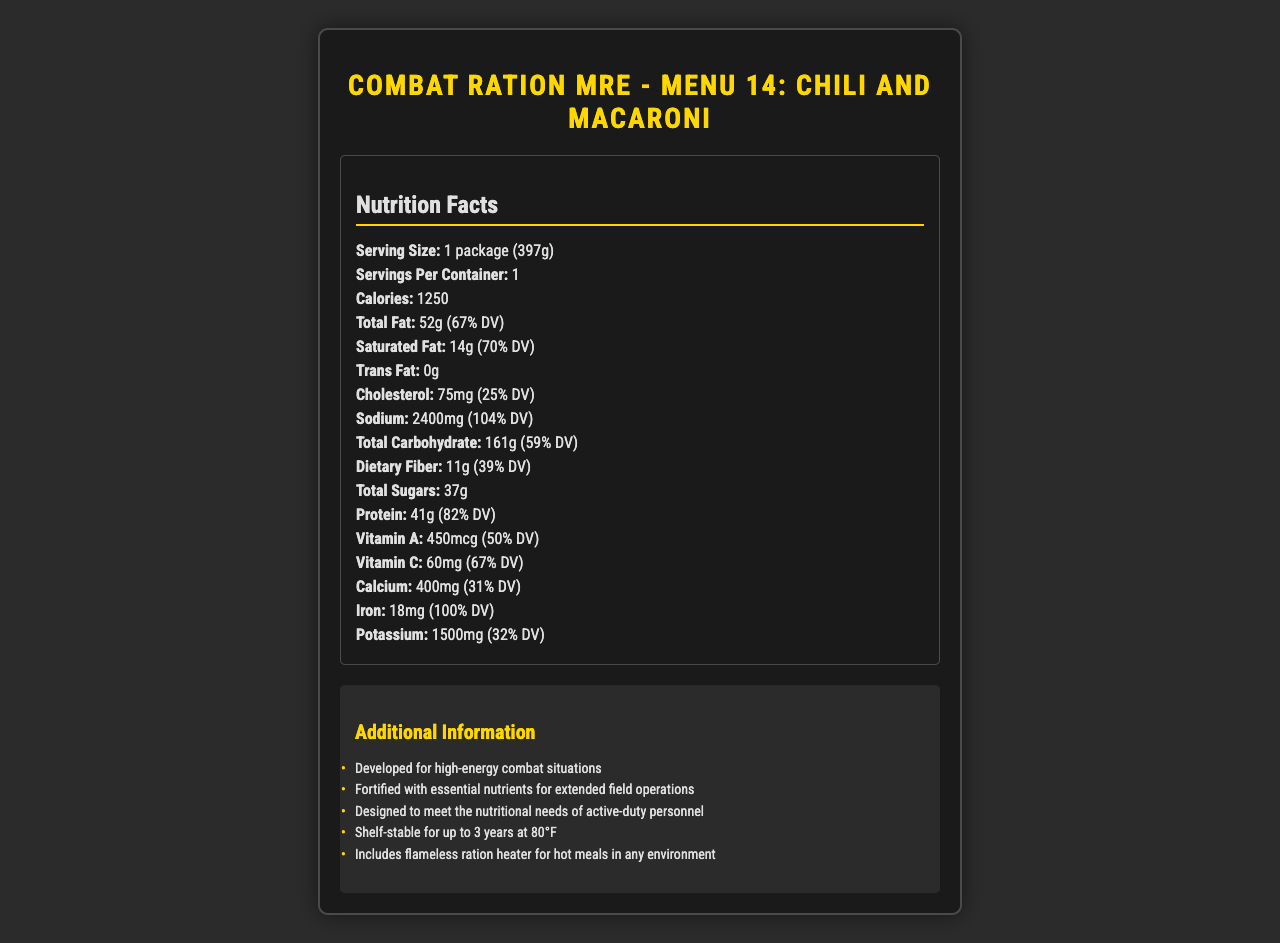what is the total fat content? The document states the total fat content is 52g, which is specified in the "Total Fat" section.
Answer: 52g how much calcium is in the MRE? In the nutrition facts, it is mentioned that Calcium amounts to 400mg.
Answer: 400mg what's the daily value percentage of vitamin B12? The document indicates that Vitamin B12 makes up 250% of the daily value.
Answer: 250% what is the serving size of this MRE? The serving size listed is "1 package (397g)".
Answer: 1 package (397g) how much protein is in the MRE? The protein content of the MRE is specified as 41g.
Answer: 41g which nutrient has the highest daily value percentage? A. Vitamin C B. Vitamin B12 C. Sodium D. Chromium Among the different nutrients, Chromium has the highest daily value percentage at 343%.
Answer: D what is the daily value percentage of iron in the MRE? A. 25% B. 67% C. 100% D. 250% The daily value percentage of iron in the MRE is 100%.
Answer: C is there any trans fat in the MRE? The document indicates 0g of trans fat.
Answer: No summarize the main idea of the document. The main idea is to present the comprehensive nutritional breakdown and specific attributes of the MRE designed for high-energy combat situations.
Answer: The document provides detailed nutritional information about "Combat Ration MRE - Menu 14: Chili and Macaroni", including caloric value, total fat, cholesterol, sodium, total carbohydrate, dietary fiber, and essential nutrients. It also gives additional information about its intended use, nutritional composition, and shelf life. does this MRE include iron? The document lists iron content as 18mg, or 100% of the daily value.
Answer: Yes how much dietary fiber is in the MRE? The dietary fiber content is listed as 11g.
Answer: 11g identify one nutrient that is particularly high in daily value percentage. Thiamin has a daily value percentage of 125%.
Answer: Thiamin (125%) what is the daily value percentage of chloride? The document lists chloride at 148% of the daily value.
Answer: 148% how long is the shelf-stable period for this MRE? It states that the MRE is shelf-stable for up to 3 years at 80°F.
Answer: Up to 3 years at 80°F how many servings are in this MRE? There is one serving per container, as indicated.
Answer: 1 what's the amount of sodium in the MRE? The sodium content is listed as 2400mg.
Answer: 2400mg does the document mention the amount of omega-3 fatty acids? The document does not provide information on omega-3 fatty acids.
Answer: Not enough information 